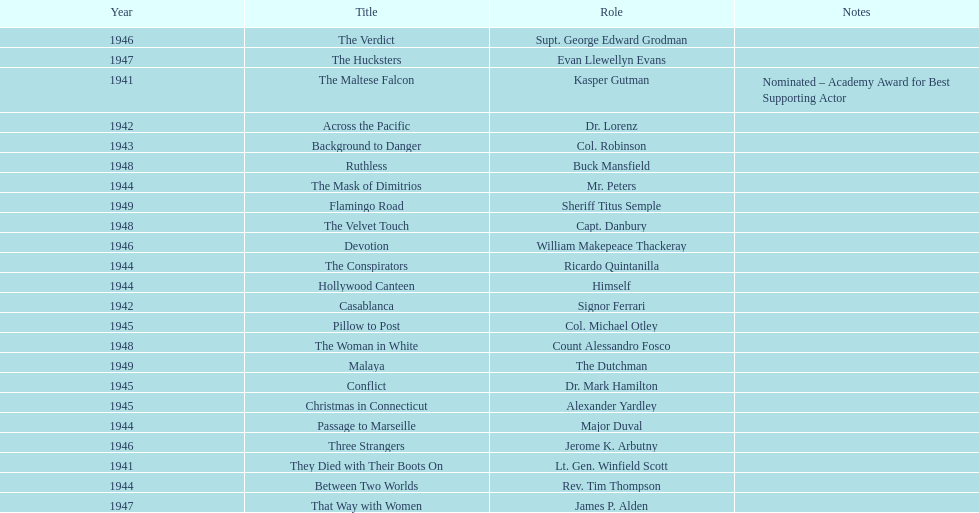How many movies has he been from 1941-1949. 23. 